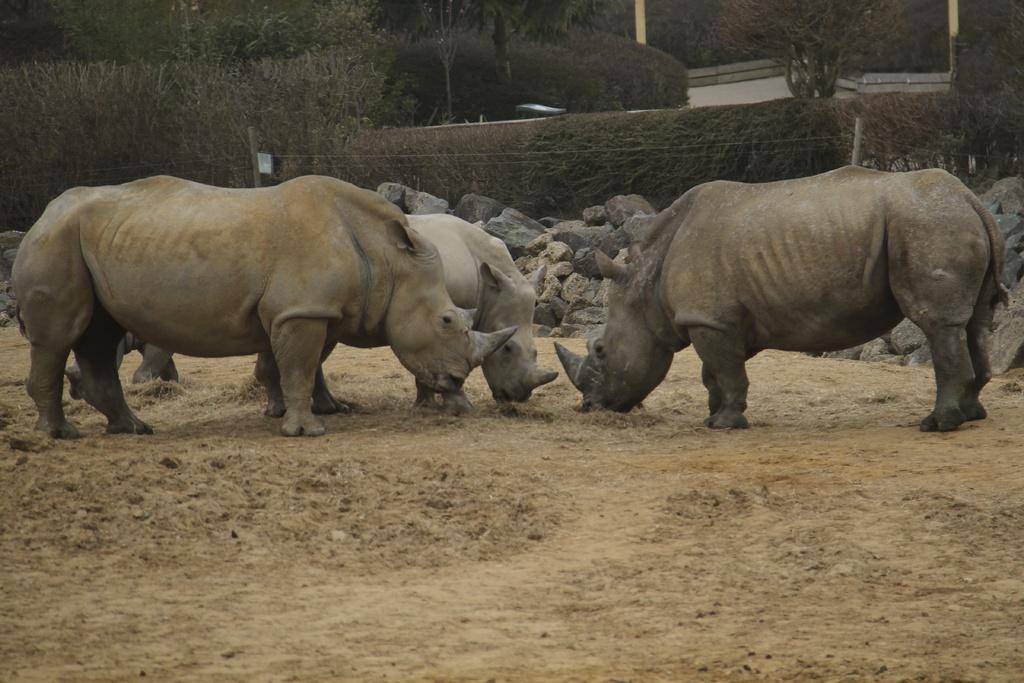What animals are present in the image? There are rhinos in the image. What is the position of the rhinos in relation to the ground? The rhinos are standing on the ground. What can be seen in the background of the image? There are stones, fences, poles, and trees in the background of the image. Where is the nest located in the image? There is no nest present in the image. How does the rhino achieve self-awareness in the image? The image does not depict the rhino's level of self-awareness; it simply shows the rhinos standing on the ground. 